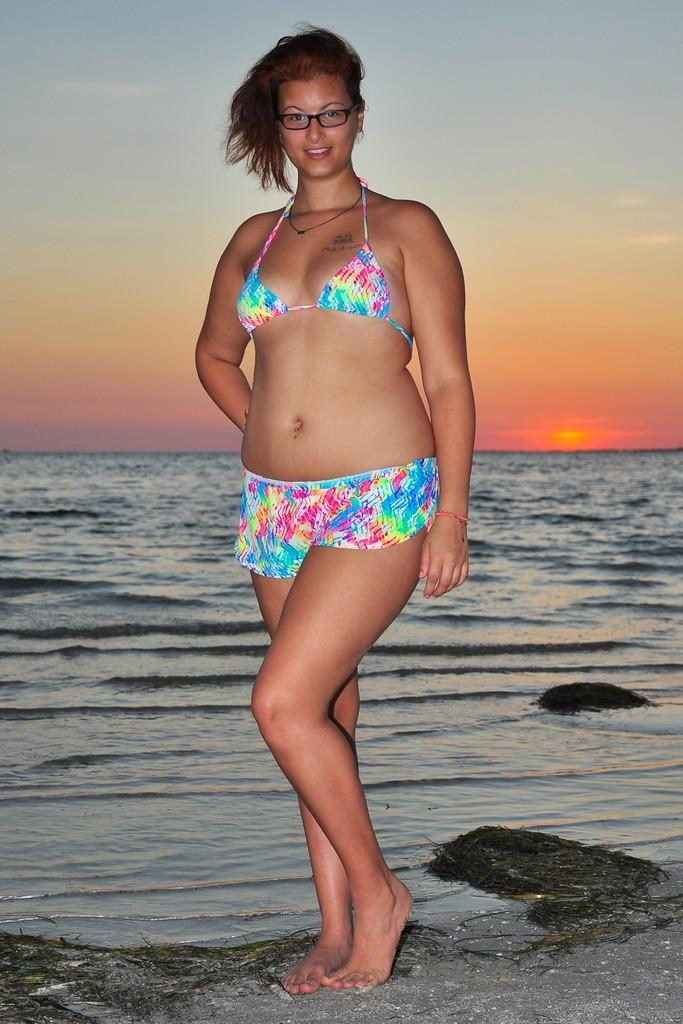Who is present in the image? There is a woman in the image. What is the woman's location in the image? The woman is standing at the sea. What can be seen in the background of the image? There is water and the sky visible in the background of the image. What type of machine can be seen operating in the background of the image? There is no machine present in the image; it features a woman standing at the sea with water and the sky visible in the background. 